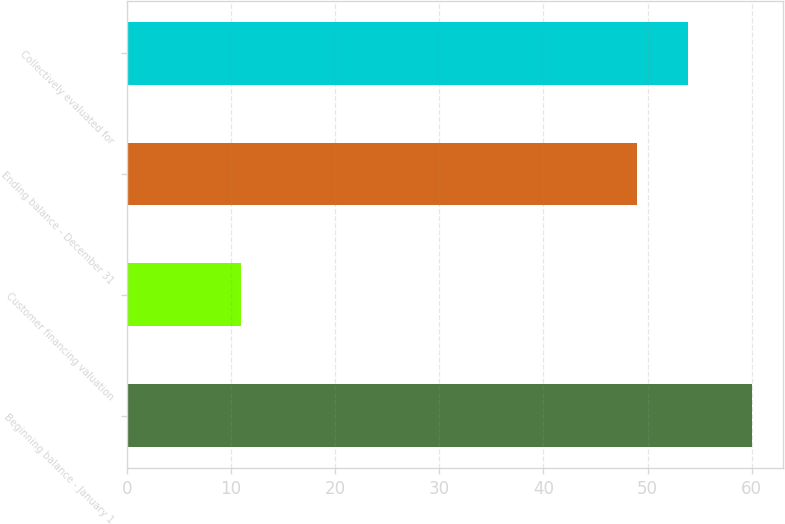<chart> <loc_0><loc_0><loc_500><loc_500><bar_chart><fcel>Beginning balance - January 1<fcel>Customer financing valuation<fcel>Ending balance - December 31<fcel>Collectively evaluated for<nl><fcel>60<fcel>11<fcel>49<fcel>53.9<nl></chart> 